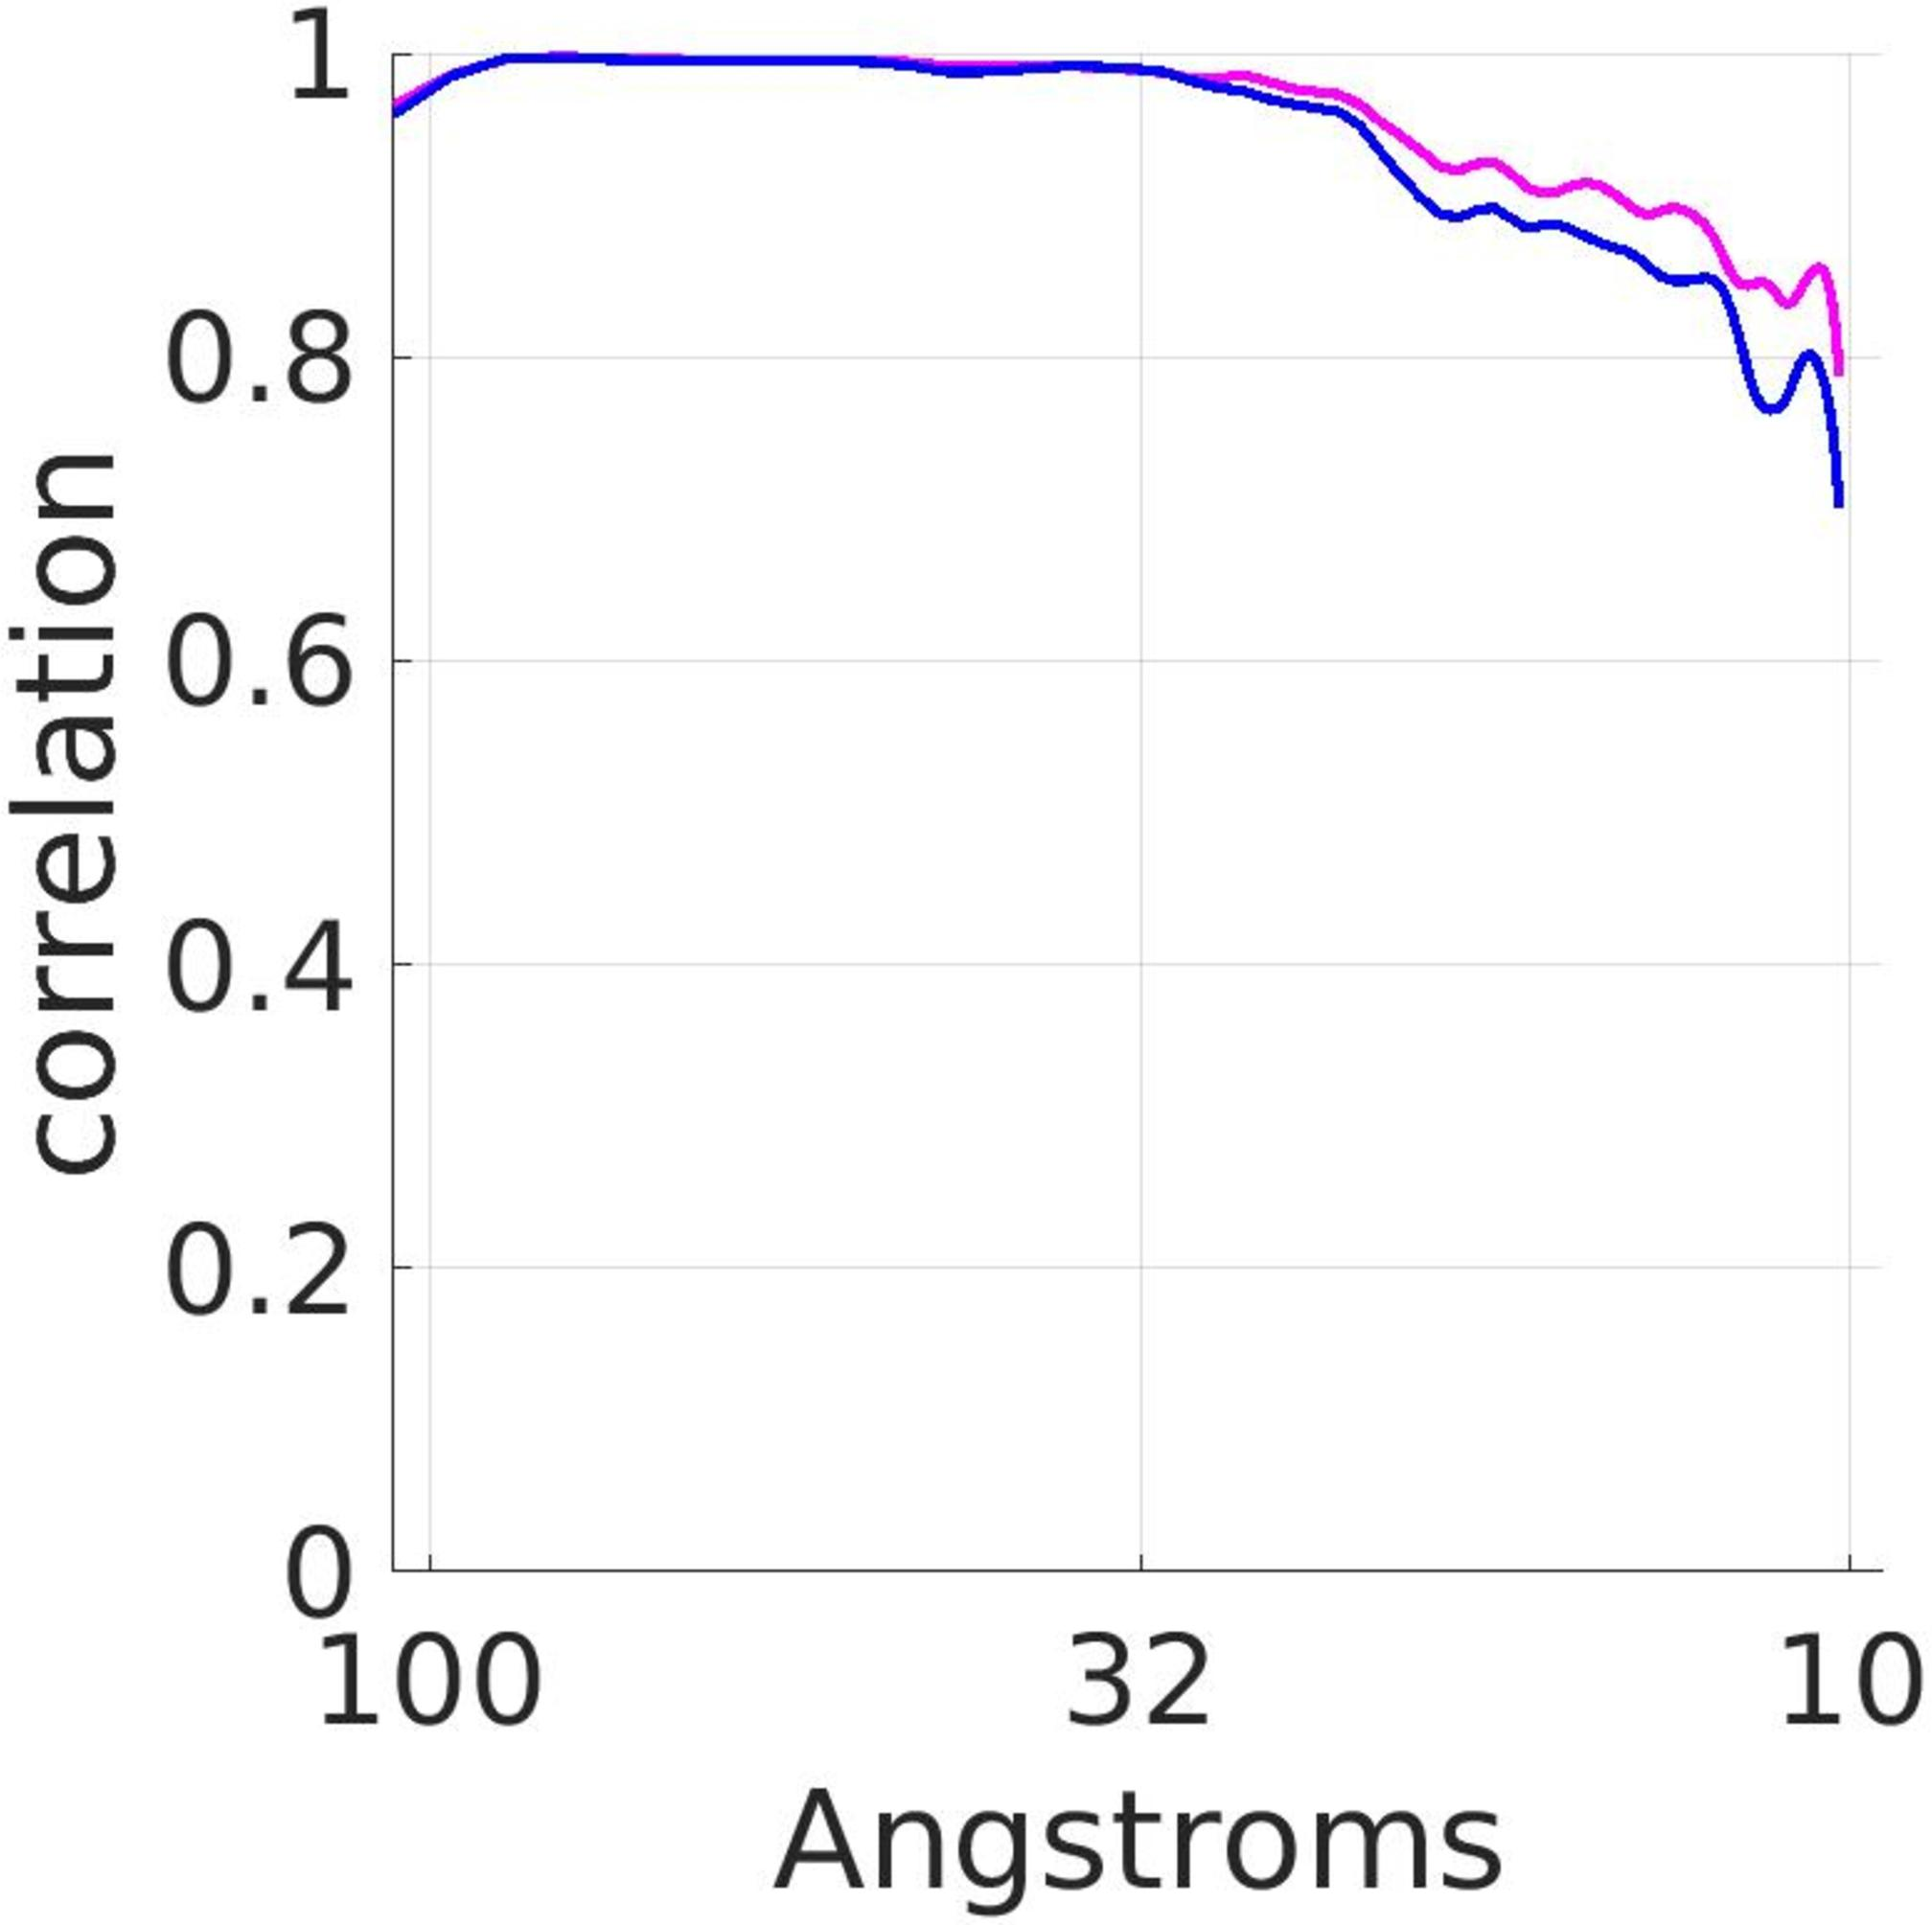What does the variability in the graph tell us about the confidence we might have in these correlation measurements at larger distances? The increasing variability in correlation observed as the distance grows suggests declining reliability in the measurements. This could be due to several factors, including measurement errors, inherent limitations in the detection technology, or physical properties affecting correlation at larger scales. Therefore, at larger distances such as 200 angstroms, our confidence in the data's predictability and accuracy is reduced. 